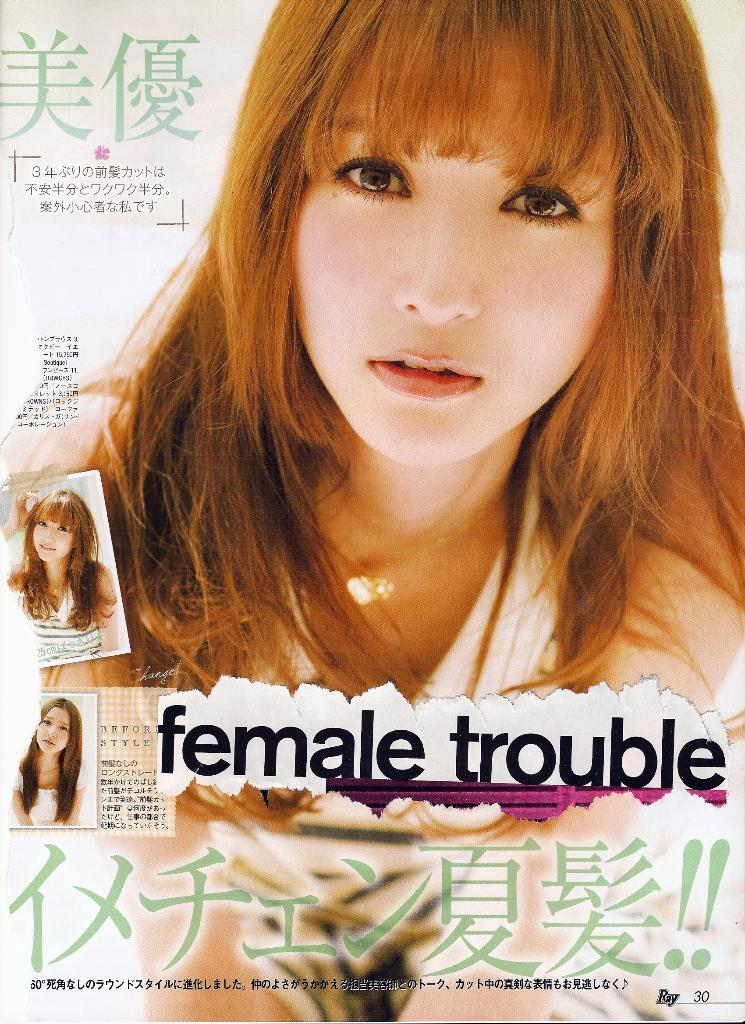What is the main object in the image? There is a paper in the image. What can be seen on the paper? There are persons depicted on the paper. Can you describe the person in front on the paper? The person in front on the paper is wearing a white dress. What else is present on the paper besides the persons? There is writing on the paper. How many boys are depicted on the paper? The provided facts do not mention any boys on the paper, so we cannot determine the number of boys depicted. 